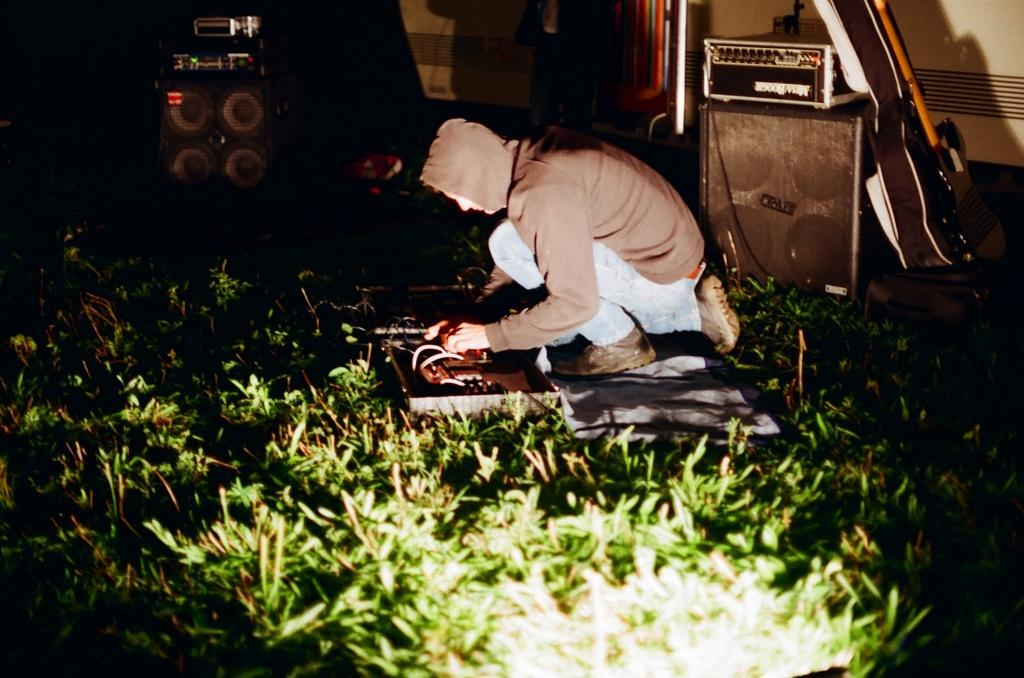Who is present in the image? There is a man in the image. What is the man's location in the image? The man is on the grass. What objects can be seen related to music in the image? There are speakers and a guitar in the image, and there are musical instruments present. What type of hen is visible in the image? There is no hen present in the image. Is the man wearing a veil in the image? The man is not wearing a veil in the image. 